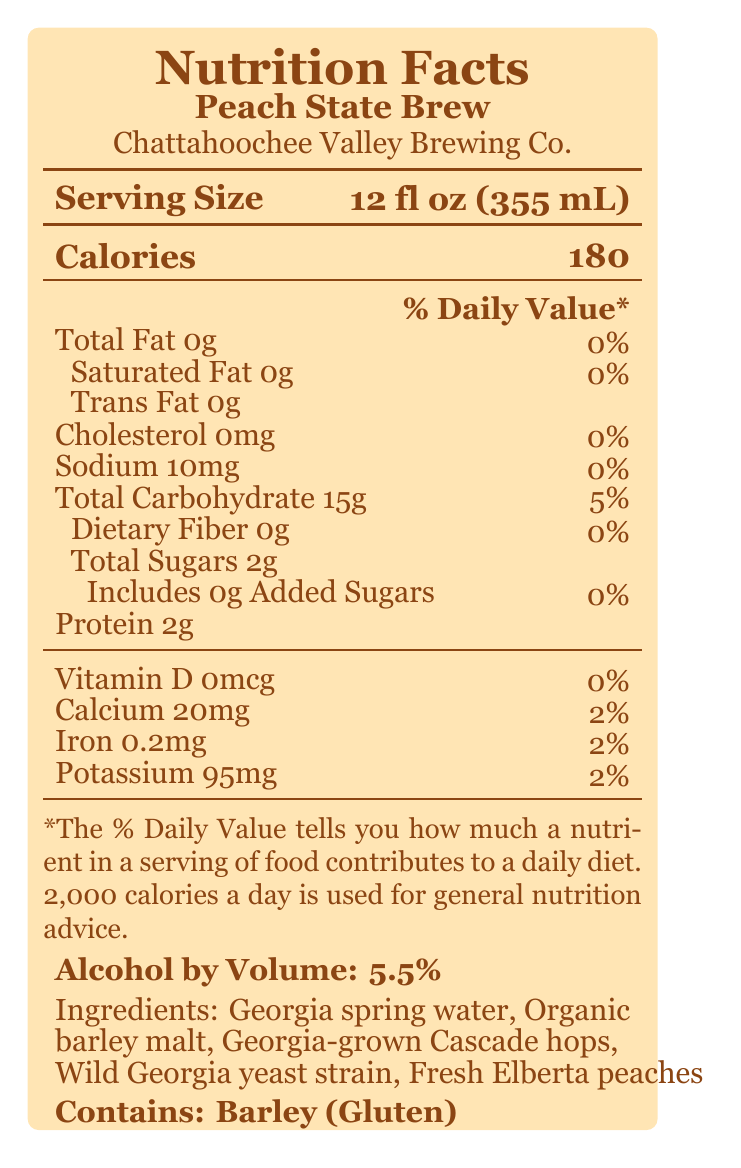what is the total fat content in Peach State Brew? The document states that the total fat content is 0g.
Answer: 0g who is the brewery behind Peach State Brew? The label mentions the brewery name as Chattahoochee Valley Brewing Co.
Answer: Chattahoochee Valley Brewing Co. how many calories are in a serving of Peach State Brew? The document specifies that there are 180 calories in a serving.
Answer: 180 what is the serving size of Peach State Brew? The serving size is indicated as 12 fl oz (355 mL).
Answer: 12 fl oz (355 mL) how much sodium is in Peach State Brew? The document lists the sodium content as 10mg.
Answer: 10mg what are the main ingredients in Peach State Brew? A. Water, barley malt, hops, yeast, peaches B. Water, barley malt, hops, yeast, sugar C. Water, barley malt, hops, yeast, corn The ingredients are listed as Georgia spring water, organic barley malt, Georgia-grown Cascade hops, wild Georgia yeast strain, and fresh Elberta peaches.
Answer: A what percentage of the daily value of calcium does Peach State Brew provide? A. 0% B. 2% C. 5% The label indicates that Peach State Brew provides 2% of the daily value of calcium.
Answer: B is Peach State Brew gluten-free? The document states that it contains barley (gluten).
Answer: No does Peach State Brew contain added sugars? The document specifies that there are 0g of added sugars.
Answer: No what is the alcohol by volume (ABV) of Peach State Brew? The label lists the ABV as 5.5%.
Answer: 5.5% what nutrient contributes to 5% of the daily value in Peach State Brew? A. Total Fat B. Total Carbohydrate C. Iron The document indicates that total carbohydrate contributes 5% of the daily value.
Answer: B explain the sustainability practices related to Peach State Brew. The document mentions that the brewery donates spent grain to local cattle farms for feed, reflecting a sustainability practice.
Answer: Spent grain is donated to local cattle farms for feed what awards has Peach State Brew won? The label mentions that Peach State Brew won the Gold Medal at the Georgia Craft Brewers Festival in 2022.
Answer: Gold Medal Winner - Georgia Craft Brewers Festival 2022 how does the brewery support local wildlife conservation efforts? The label states that part of the proceeds goes towards supporting the Georgia Department of Natural Resources’ wildlife conservation efforts.
Answer: A portion of proceeds supports the Georgia Department of Natural Resources' wildlife conservation efforts summarize the main idea of this document. The document includes detailed nutritional information, ingredients, brewery notes, sustainability practices, and conservation statements for Peach State Brew, emphasizing its local origin and community support.
Answer: The document provides nutrition facts and additional information for Peach State Brew, a craft beer made by Chattahoochee Valley Brewing Co. It highlights the use of native Georgia ingredients and local connections, mentions its sustainability practices, and notes that a portion of proceeds supports wildlife conservation efforts. how many grams of fiber are in Peach State Brew? The document states that there are 0g of dietary fiber.
Answer: 0g where are the peaches in Peach State Brew sourced from? The document indicates that the peaches are sourced from Dickey Farms in Musella, GA.
Answer: Dickey Farms in Musella, GA what is the content of vitamin D in Peach State Brew? The document lists the vitamin D content as 0mcg.
Answer: 0mcg does the label mention anything about the carbohydrate content being moderate or high in Peach State Brew? The label mentions the carbohydrate content as 15g, but it does not explicitly state if it is moderate or high.
Answer: Not enough information what is the accepted range for daily calorie intake according to the document? The document notes that 2,000 calories a day is used for general nutrition advice.
Answer: 2,000 calories 